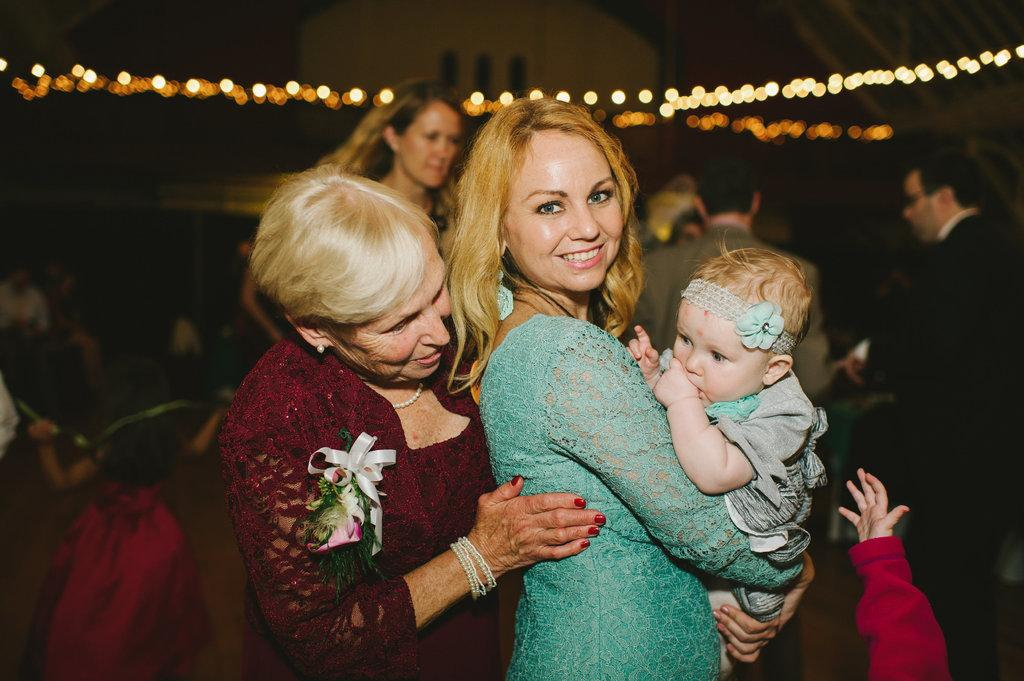What is the main subject of the image? The main subject of the image is women standing in the center. Can you describe the background of the image? There are persons and lighting visible in the background, as well as a building. What type of lettuce is being used as a prop by the women in the image? There is no lettuce present in the image, and the women are not using any props. 